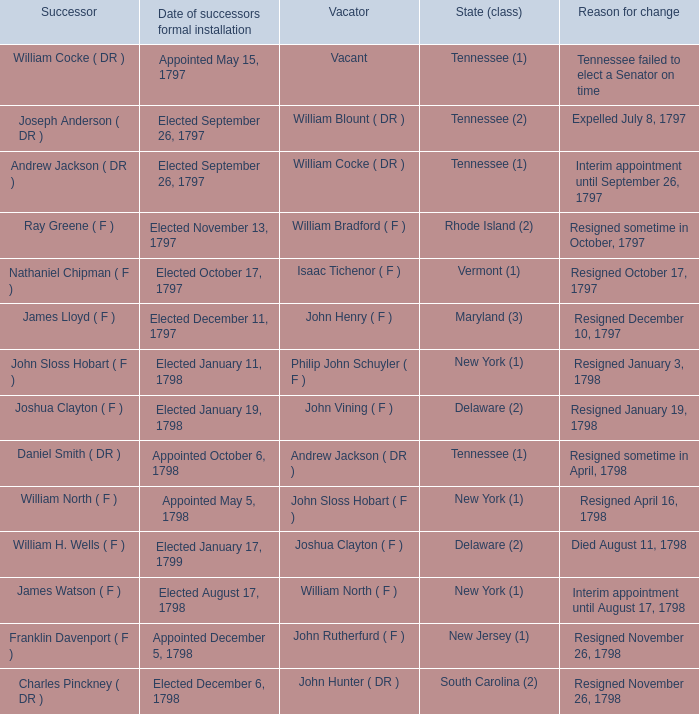What is the total number of successors when the vacator was William North ( F ) 1.0. 